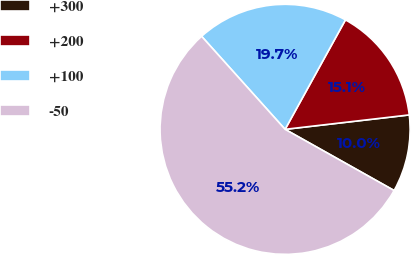<chart> <loc_0><loc_0><loc_500><loc_500><pie_chart><fcel>+300<fcel>+200<fcel>+100<fcel>-50<nl><fcel>9.98%<fcel>15.14%<fcel>19.66%<fcel>55.22%<nl></chart> 